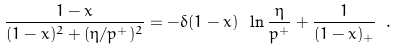Convert formula to latex. <formula><loc_0><loc_0><loc_500><loc_500>\frac { 1 - x } { ( 1 - x ) ^ { 2 } + ( \eta / p ^ { + } ) ^ { 2 } } = - \delta ( 1 - x ) \ \ln \frac { \eta } { p ^ { + } } + \frac { 1 } { ( 1 - x ) _ { + } } \ .</formula> 